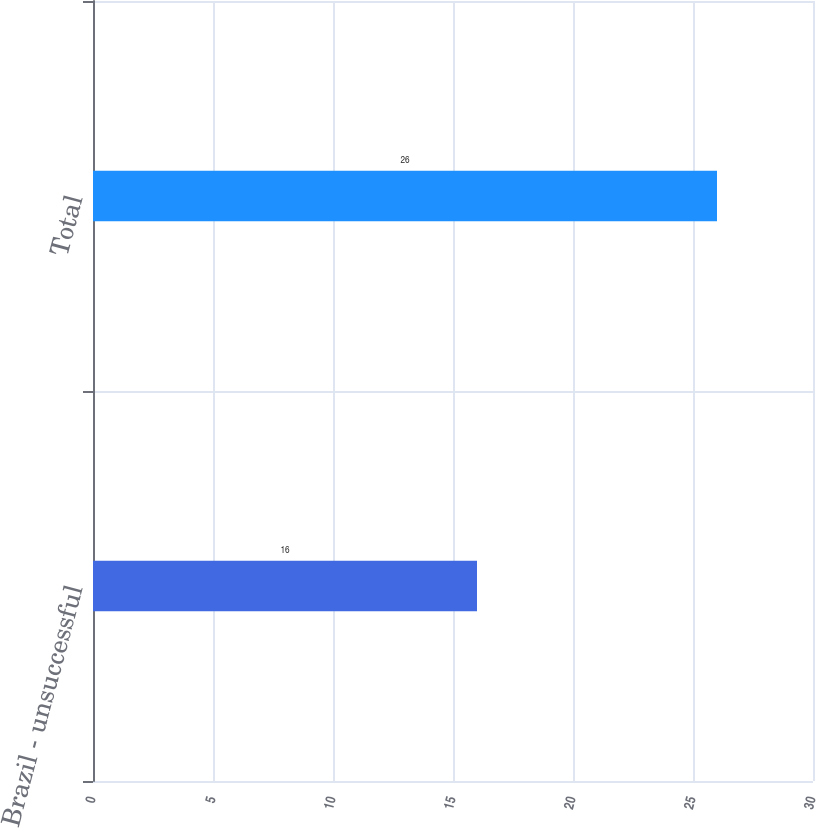Convert chart. <chart><loc_0><loc_0><loc_500><loc_500><bar_chart><fcel>Brazil - unsuccessful<fcel>Total<nl><fcel>16<fcel>26<nl></chart> 